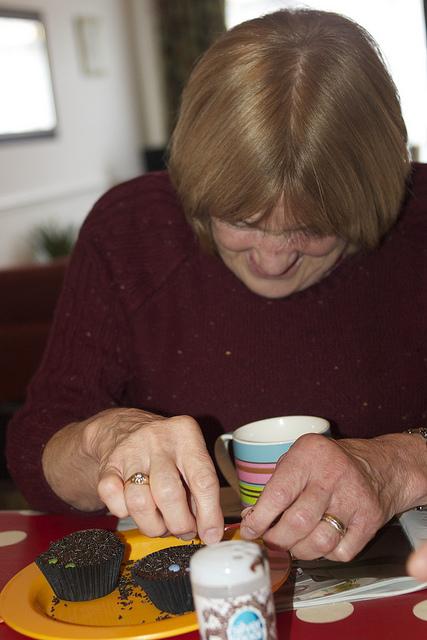Is she young?
Give a very brief answer. No. What is she making?
Write a very short answer. Cupcakes. Could she be married?
Keep it brief. Yes. 